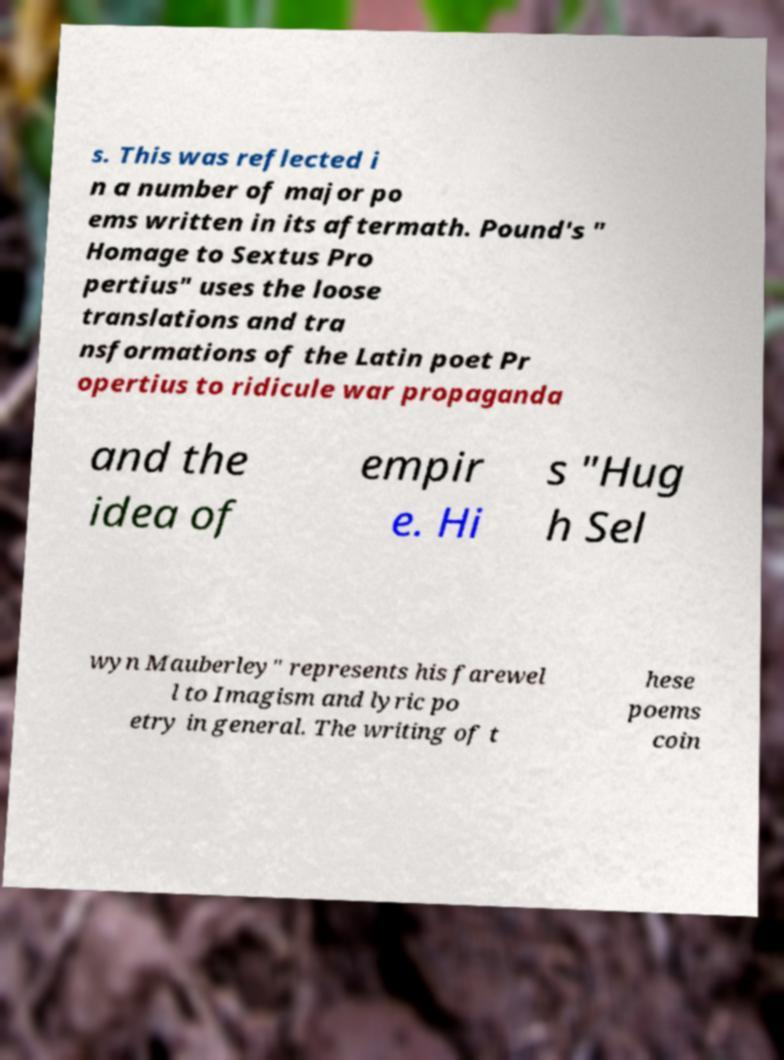I need the written content from this picture converted into text. Can you do that? s. This was reflected i n a number of major po ems written in its aftermath. Pound's " Homage to Sextus Pro pertius" uses the loose translations and tra nsformations of the Latin poet Pr opertius to ridicule war propaganda and the idea of empir e. Hi s "Hug h Sel wyn Mauberley" represents his farewel l to Imagism and lyric po etry in general. The writing of t hese poems coin 